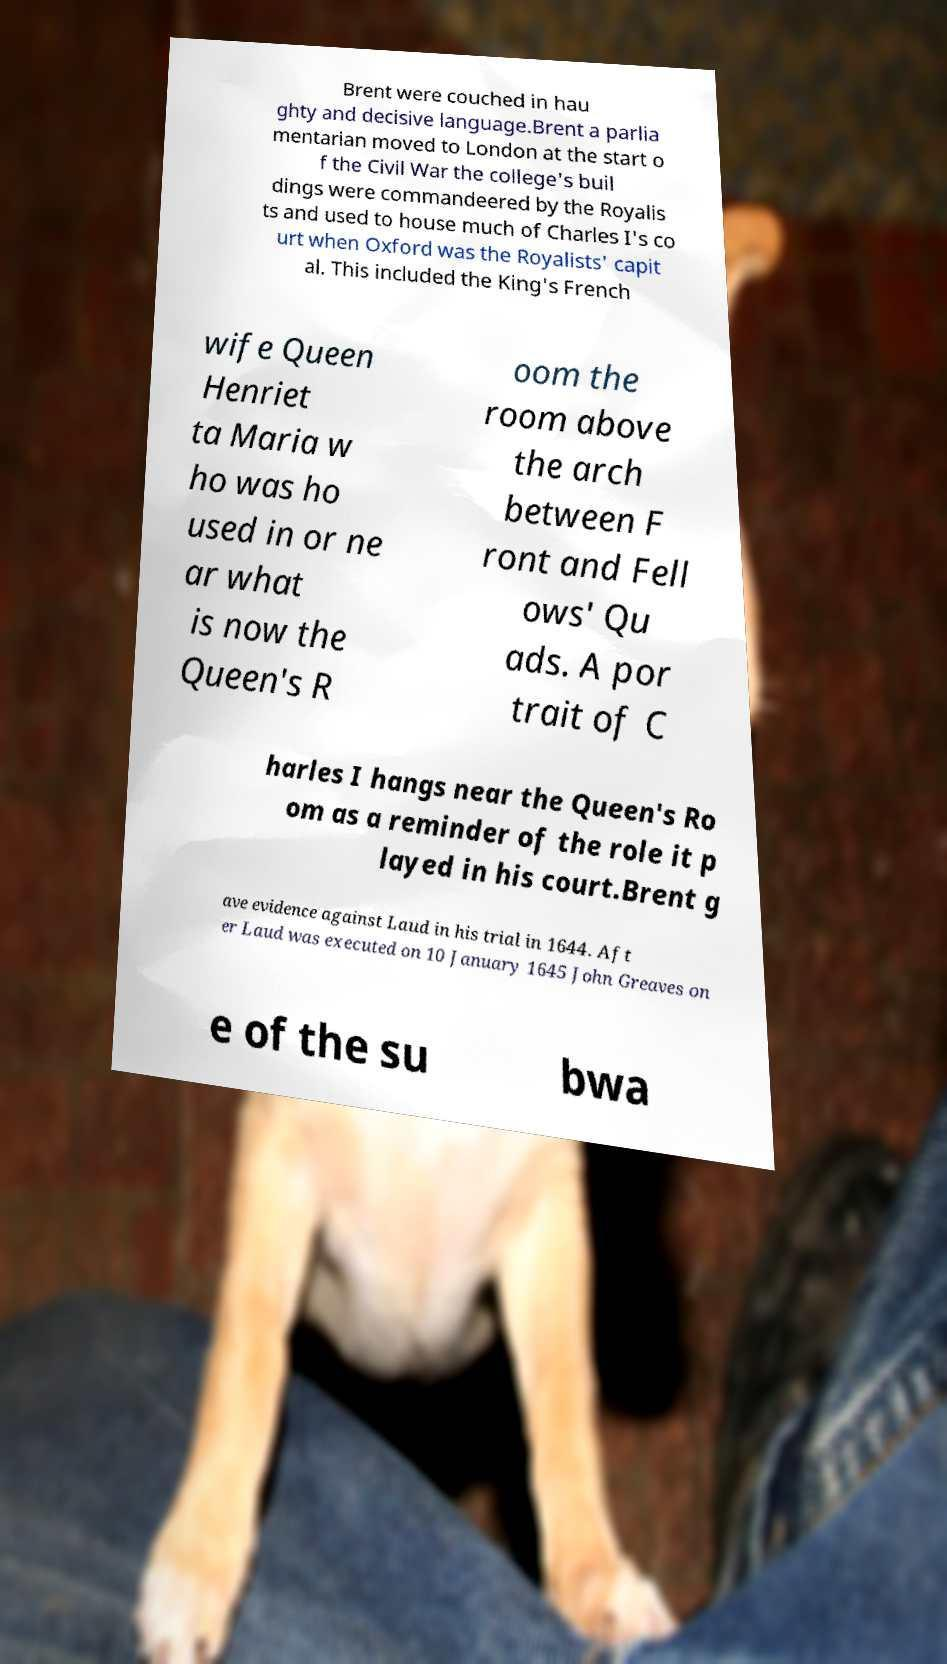Can you read and provide the text displayed in the image?This photo seems to have some interesting text. Can you extract and type it out for me? Brent were couched in hau ghty and decisive language.Brent a parlia mentarian moved to London at the start o f the Civil War the college's buil dings were commandeered by the Royalis ts and used to house much of Charles I's co urt when Oxford was the Royalists' capit al. This included the King's French wife Queen Henriet ta Maria w ho was ho used in or ne ar what is now the Queen's R oom the room above the arch between F ront and Fell ows' Qu ads. A por trait of C harles I hangs near the Queen's Ro om as a reminder of the role it p layed in his court.Brent g ave evidence against Laud in his trial in 1644. Aft er Laud was executed on 10 January 1645 John Greaves on e of the su bwa 